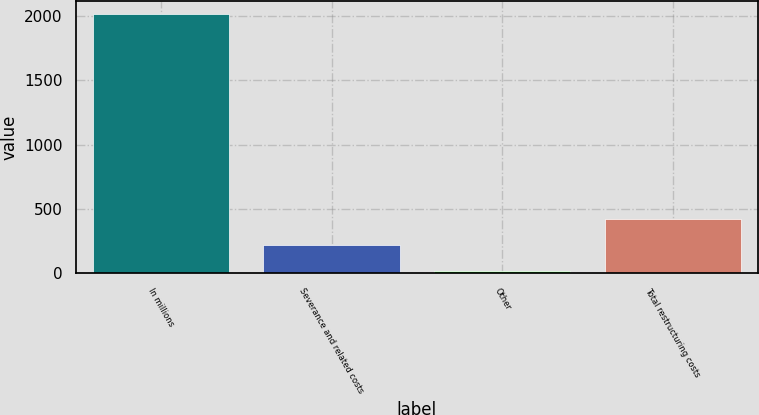Convert chart. <chart><loc_0><loc_0><loc_500><loc_500><bar_chart><fcel>In millions<fcel>Severance and related costs<fcel>Other<fcel>Total restructuring costs<nl><fcel>2013<fcel>220.83<fcel>21.7<fcel>419.96<nl></chart> 